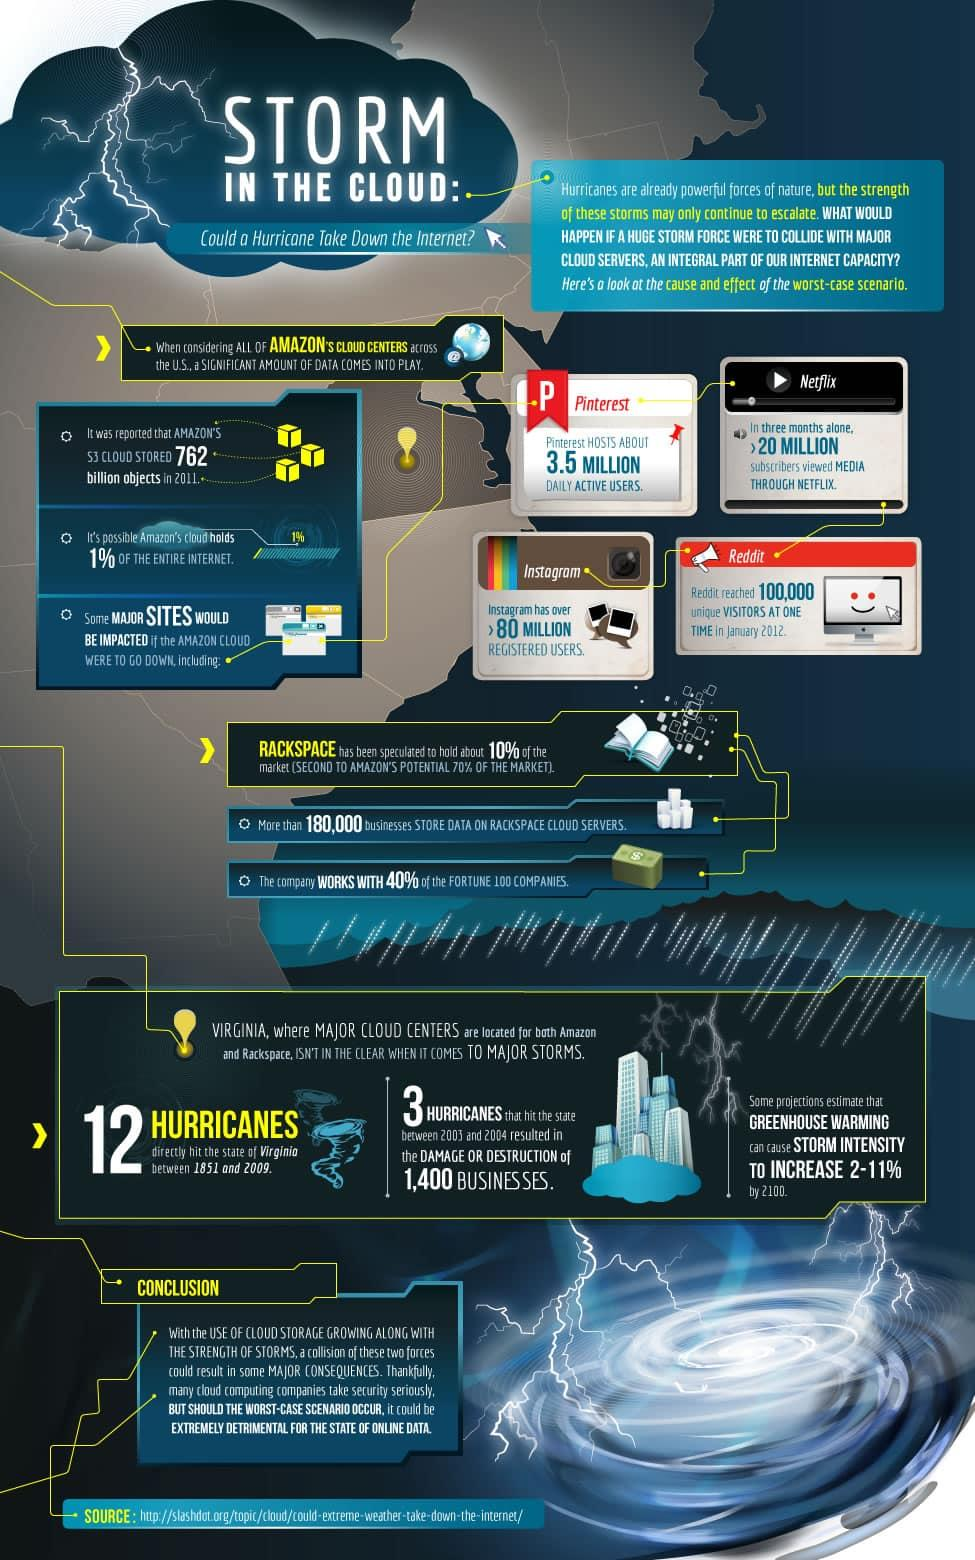Point out several critical features in this image. In the span of 1.5 centuries, a total of 12 hurricanes have hit the state of Virginia. Between the years 2004 and 2004, there were a total of 3 hurricanes. Pinterest has 3.5 million active daily users. In the most recent quarter of the year, more than 20 million subscribers viewed media through Netflix, a significant increase from previous quarters. There are currently over 80 million registered users on Instagram. 